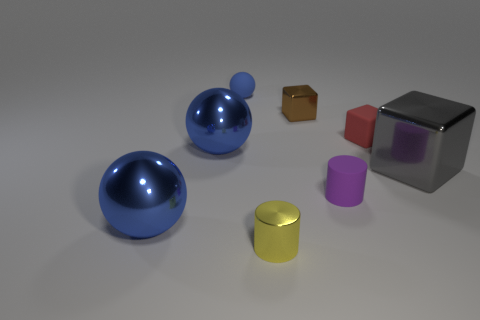There is a tiny matte block; is it the same color as the metallic cube that is to the left of the large gray block?
Ensure brevity in your answer.  No. Is there a large metal ball that has the same color as the tiny matte sphere?
Offer a very short reply. Yes. Is the material of the tiny red object the same as the tiny thing behind the tiny brown object?
Your response must be concise. Yes. What number of tiny objects are either blue shiny things or spheres?
Offer a very short reply. 1. Are there fewer large yellow matte balls than blue rubber objects?
Give a very brief answer. Yes. Do the blue metallic sphere behind the purple rubber thing and the ball that is behind the red rubber thing have the same size?
Your answer should be compact. No. How many brown things are either tiny rubber cylinders or metallic blocks?
Ensure brevity in your answer.  1. Are there more big gray cubes than big purple rubber balls?
Provide a succinct answer. Yes. What number of things are either yellow balls or metallic objects that are left of the purple matte object?
Provide a short and direct response. 4. What number of other things are the same shape as the red matte thing?
Your answer should be compact. 2. 